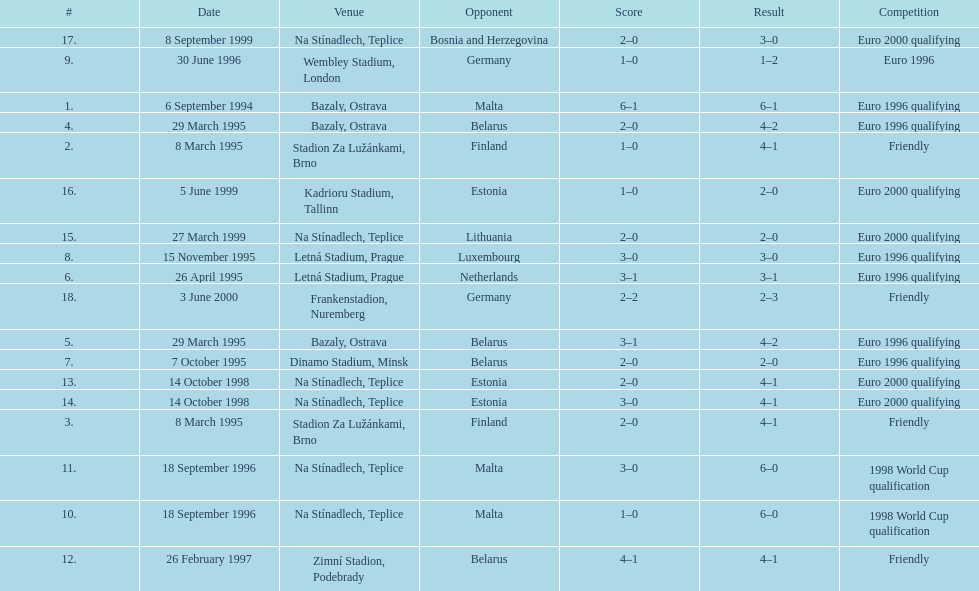Bazaly, ostrava was used on 6 september 1004, but what venue was used on 18 september 1996? Na Stínadlech, Teplice. 